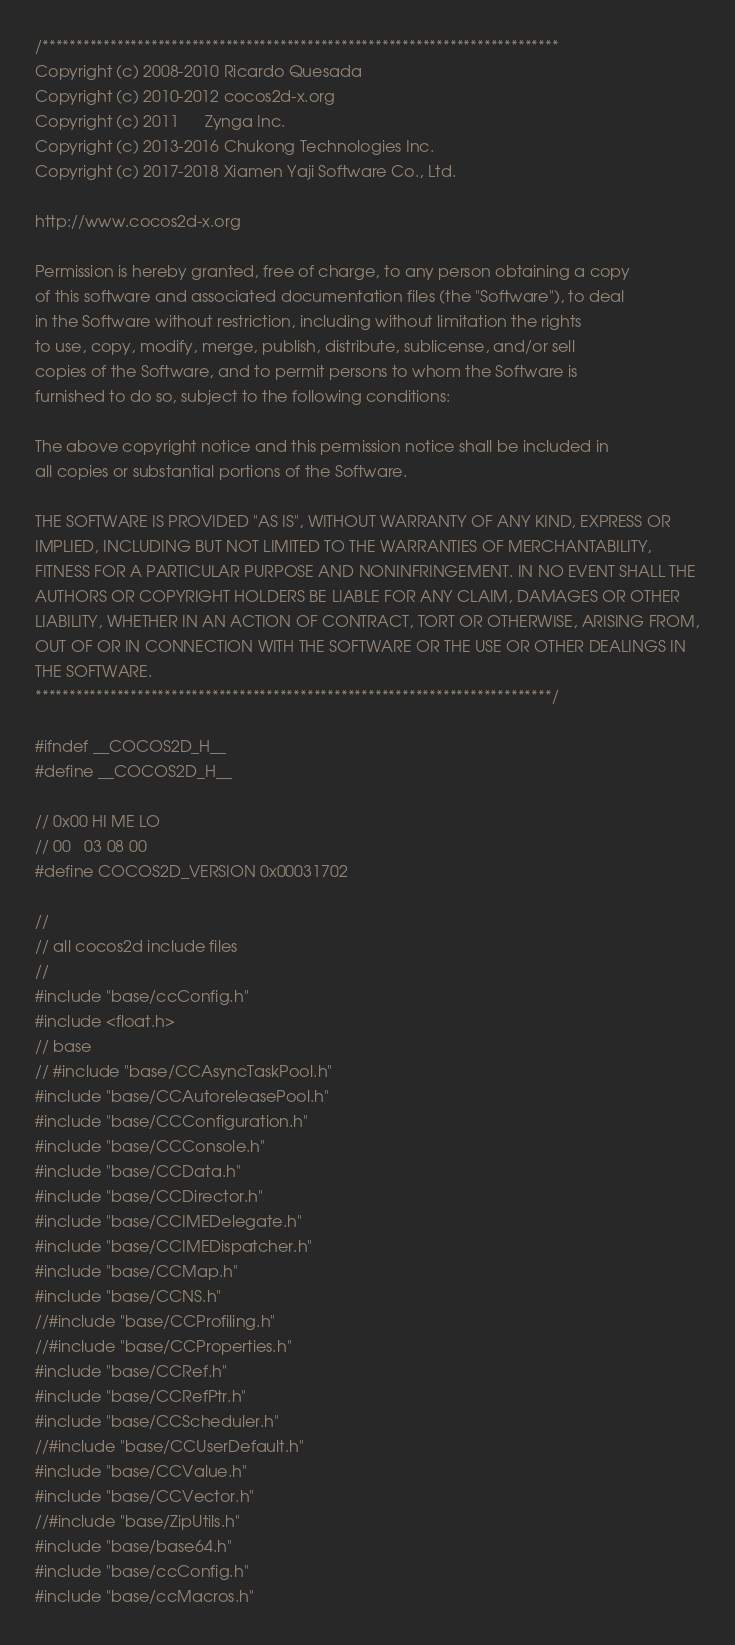Convert code to text. <code><loc_0><loc_0><loc_500><loc_500><_C_>/****************************************************************************
Copyright (c) 2008-2010 Ricardo Quesada
Copyright (c) 2010-2012 cocos2d-x.org
Copyright (c) 2011      Zynga Inc.
Copyright (c) 2013-2016 Chukong Technologies Inc.
Copyright (c) 2017-2018 Xiamen Yaji Software Co., Ltd.

http://www.cocos2d-x.org

Permission is hereby granted, free of charge, to any person obtaining a copy
of this software and associated documentation files (the "Software"), to deal
in the Software without restriction, including without limitation the rights
to use, copy, modify, merge, publish, distribute, sublicense, and/or sell
copies of the Software, and to permit persons to whom the Software is
furnished to do so, subject to the following conditions:

The above copyright notice and this permission notice shall be included in
all copies or substantial portions of the Software.

THE SOFTWARE IS PROVIDED "AS IS", WITHOUT WARRANTY OF ANY KIND, EXPRESS OR
IMPLIED, INCLUDING BUT NOT LIMITED TO THE WARRANTIES OF MERCHANTABILITY,
FITNESS FOR A PARTICULAR PURPOSE AND NONINFRINGEMENT. IN NO EVENT SHALL THE
AUTHORS OR COPYRIGHT HOLDERS BE LIABLE FOR ANY CLAIM, DAMAGES OR OTHER
LIABILITY, WHETHER IN AN ACTION OF CONTRACT, TORT OR OTHERWISE, ARISING FROM,
OUT OF OR IN CONNECTION WITH THE SOFTWARE OR THE USE OR OTHER DEALINGS IN
THE SOFTWARE.
****************************************************************************/

#ifndef __COCOS2D_H__
#define __COCOS2D_H__

// 0x00 HI ME LO
// 00   03 08 00
#define COCOS2D_VERSION 0x00031702

//
// all cocos2d include files
//
#include "base/ccConfig.h"
#include <float.h>
// base
// #include "base/CCAsyncTaskPool.h"
#include "base/CCAutoreleasePool.h"
#include "base/CCConfiguration.h"
#include "base/CCConsole.h"
#include "base/CCData.h"
#include "base/CCDirector.h"
#include "base/CCIMEDelegate.h"
#include "base/CCIMEDispatcher.h"
#include "base/CCMap.h"
#include "base/CCNS.h"
//#include "base/CCProfiling.h"
//#include "base/CCProperties.h"
#include "base/CCRef.h"
#include "base/CCRefPtr.h"
#include "base/CCScheduler.h"
//#include "base/CCUserDefault.h"
#include "base/CCValue.h"
#include "base/CCVector.h"
//#include "base/ZipUtils.h"
#include "base/base64.h"
#include "base/ccConfig.h"
#include "base/ccMacros.h"</code> 